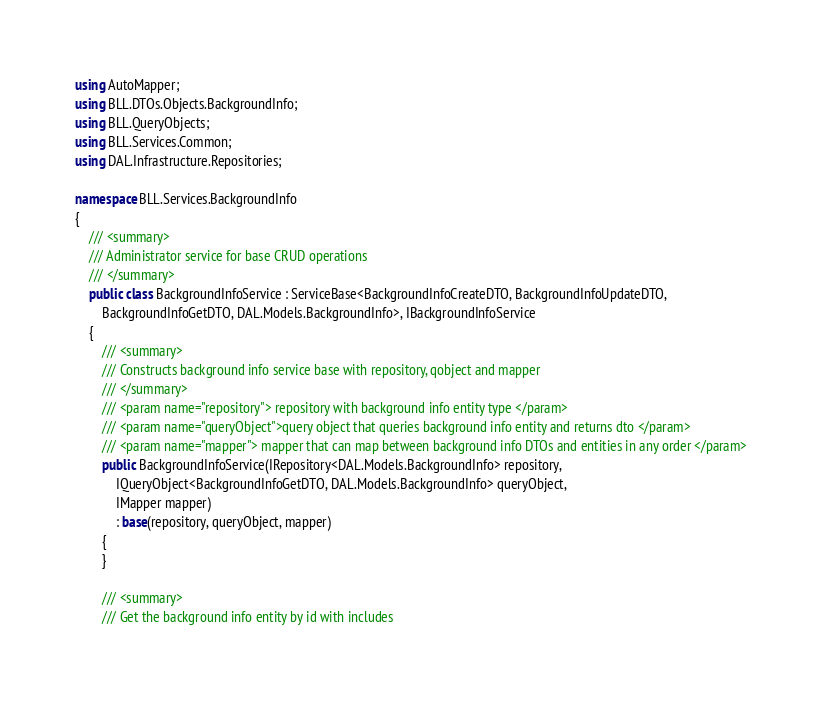Convert code to text. <code><loc_0><loc_0><loc_500><loc_500><_C#_>using AutoMapper;
using BLL.DTOs.Objects.BackgroundInfo;
using BLL.QueryObjects;
using BLL.Services.Common;
using DAL.Infrastructure.Repositories;

namespace BLL.Services.BackgroundInfo
{
    /// <summary>
    /// Administrator service for base CRUD operations
    /// </summary>
    public class BackgroundInfoService : ServiceBase<BackgroundInfoCreateDTO, BackgroundInfoUpdateDTO,
        BackgroundInfoGetDTO, DAL.Models.BackgroundInfo>, IBackgroundInfoService
    {
        /// <summary>
        /// Constructs background info service base with repository, qobject and mapper
        /// </summary>
        /// <param name="repository"> repository with background info entity type </param>
        /// <param name="queryObject">query object that queries background info entity and returns dto </param>
        /// <param name="mapper"> mapper that can map between background info DTOs and entities in any order </param>
        public BackgroundInfoService(IRepository<DAL.Models.BackgroundInfo> repository,
            IQueryObject<BackgroundInfoGetDTO, DAL.Models.BackgroundInfo> queryObject,
            IMapper mapper)
            : base(repository, queryObject, mapper)
        {
        }

        /// <summary>
        /// Get the background info entity by id with includes</code> 